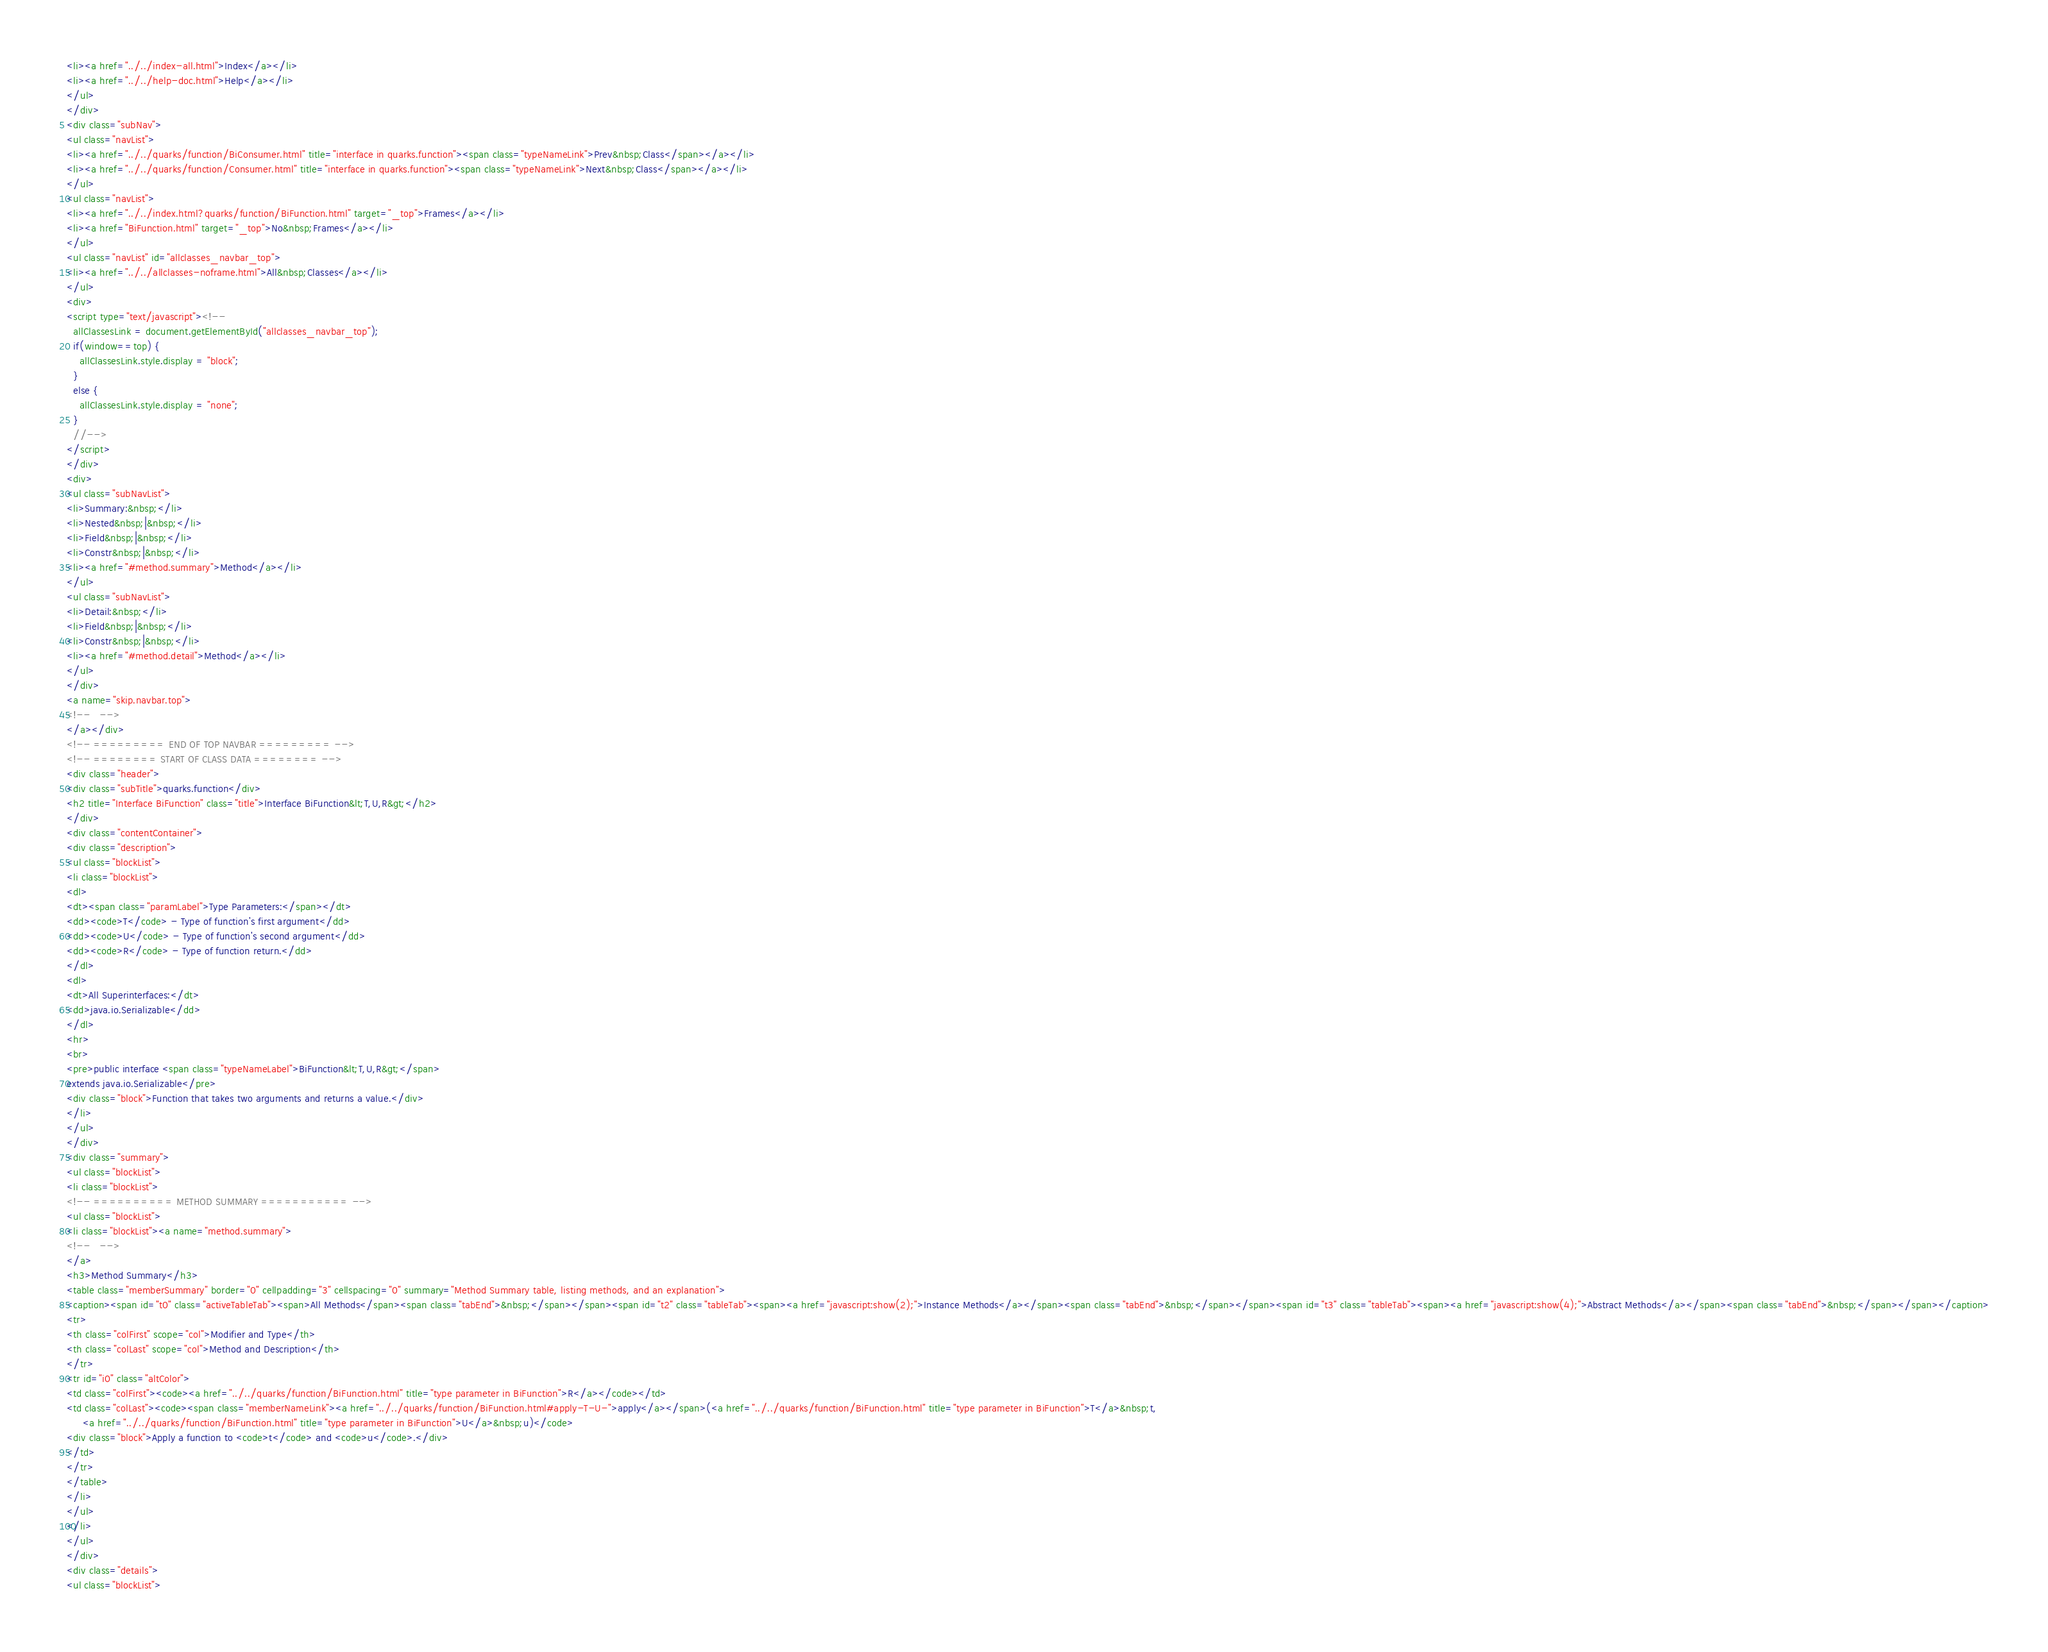<code> <loc_0><loc_0><loc_500><loc_500><_HTML_><li><a href="../../index-all.html">Index</a></li>
<li><a href="../../help-doc.html">Help</a></li>
</ul>
</div>
<div class="subNav">
<ul class="navList">
<li><a href="../../quarks/function/BiConsumer.html" title="interface in quarks.function"><span class="typeNameLink">Prev&nbsp;Class</span></a></li>
<li><a href="../../quarks/function/Consumer.html" title="interface in quarks.function"><span class="typeNameLink">Next&nbsp;Class</span></a></li>
</ul>
<ul class="navList">
<li><a href="../../index.html?quarks/function/BiFunction.html" target="_top">Frames</a></li>
<li><a href="BiFunction.html" target="_top">No&nbsp;Frames</a></li>
</ul>
<ul class="navList" id="allclasses_navbar_top">
<li><a href="../../allclasses-noframe.html">All&nbsp;Classes</a></li>
</ul>
<div>
<script type="text/javascript"><!--
  allClassesLink = document.getElementById("allclasses_navbar_top");
  if(window==top) {
    allClassesLink.style.display = "block";
  }
  else {
    allClassesLink.style.display = "none";
  }
  //-->
</script>
</div>
<div>
<ul class="subNavList">
<li>Summary:&nbsp;</li>
<li>Nested&nbsp;|&nbsp;</li>
<li>Field&nbsp;|&nbsp;</li>
<li>Constr&nbsp;|&nbsp;</li>
<li><a href="#method.summary">Method</a></li>
</ul>
<ul class="subNavList">
<li>Detail:&nbsp;</li>
<li>Field&nbsp;|&nbsp;</li>
<li>Constr&nbsp;|&nbsp;</li>
<li><a href="#method.detail">Method</a></li>
</ul>
</div>
<a name="skip.navbar.top">
<!--   -->
</a></div>
<!-- ========= END OF TOP NAVBAR ========= -->
<!-- ======== START OF CLASS DATA ======== -->
<div class="header">
<div class="subTitle">quarks.function</div>
<h2 title="Interface BiFunction" class="title">Interface BiFunction&lt;T,U,R&gt;</h2>
</div>
<div class="contentContainer">
<div class="description">
<ul class="blockList">
<li class="blockList">
<dl>
<dt><span class="paramLabel">Type Parameters:</span></dt>
<dd><code>T</code> - Type of function's first argument</dd>
<dd><code>U</code> - Type of function's second argument</dd>
<dd><code>R</code> - Type of function return.</dd>
</dl>
<dl>
<dt>All Superinterfaces:</dt>
<dd>java.io.Serializable</dd>
</dl>
<hr>
<br>
<pre>public interface <span class="typeNameLabel">BiFunction&lt;T,U,R&gt;</span>
extends java.io.Serializable</pre>
<div class="block">Function that takes two arguments and returns a value.</div>
</li>
</ul>
</div>
<div class="summary">
<ul class="blockList">
<li class="blockList">
<!-- ========== METHOD SUMMARY =========== -->
<ul class="blockList">
<li class="blockList"><a name="method.summary">
<!--   -->
</a>
<h3>Method Summary</h3>
<table class="memberSummary" border="0" cellpadding="3" cellspacing="0" summary="Method Summary table, listing methods, and an explanation">
<caption><span id="t0" class="activeTableTab"><span>All Methods</span><span class="tabEnd">&nbsp;</span></span><span id="t2" class="tableTab"><span><a href="javascript:show(2);">Instance Methods</a></span><span class="tabEnd">&nbsp;</span></span><span id="t3" class="tableTab"><span><a href="javascript:show(4);">Abstract Methods</a></span><span class="tabEnd">&nbsp;</span></span></caption>
<tr>
<th class="colFirst" scope="col">Modifier and Type</th>
<th class="colLast" scope="col">Method and Description</th>
</tr>
<tr id="i0" class="altColor">
<td class="colFirst"><code><a href="../../quarks/function/BiFunction.html" title="type parameter in BiFunction">R</a></code></td>
<td class="colLast"><code><span class="memberNameLink"><a href="../../quarks/function/BiFunction.html#apply-T-U-">apply</a></span>(<a href="../../quarks/function/BiFunction.html" title="type parameter in BiFunction">T</a>&nbsp;t,
     <a href="../../quarks/function/BiFunction.html" title="type parameter in BiFunction">U</a>&nbsp;u)</code>
<div class="block">Apply a function to <code>t</code> and <code>u</code>.</div>
</td>
</tr>
</table>
</li>
</ul>
</li>
</ul>
</div>
<div class="details">
<ul class="blockList"></code> 